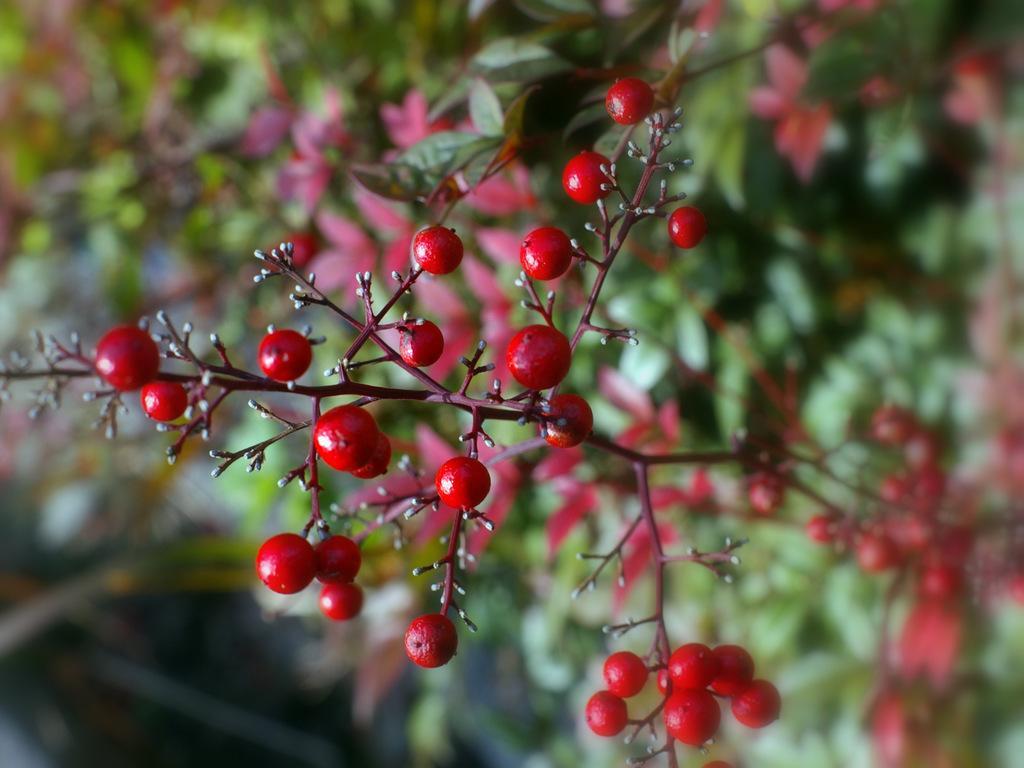How would you summarize this image in a sentence or two? In this image we can see many plants. There are fruits to the plant. 